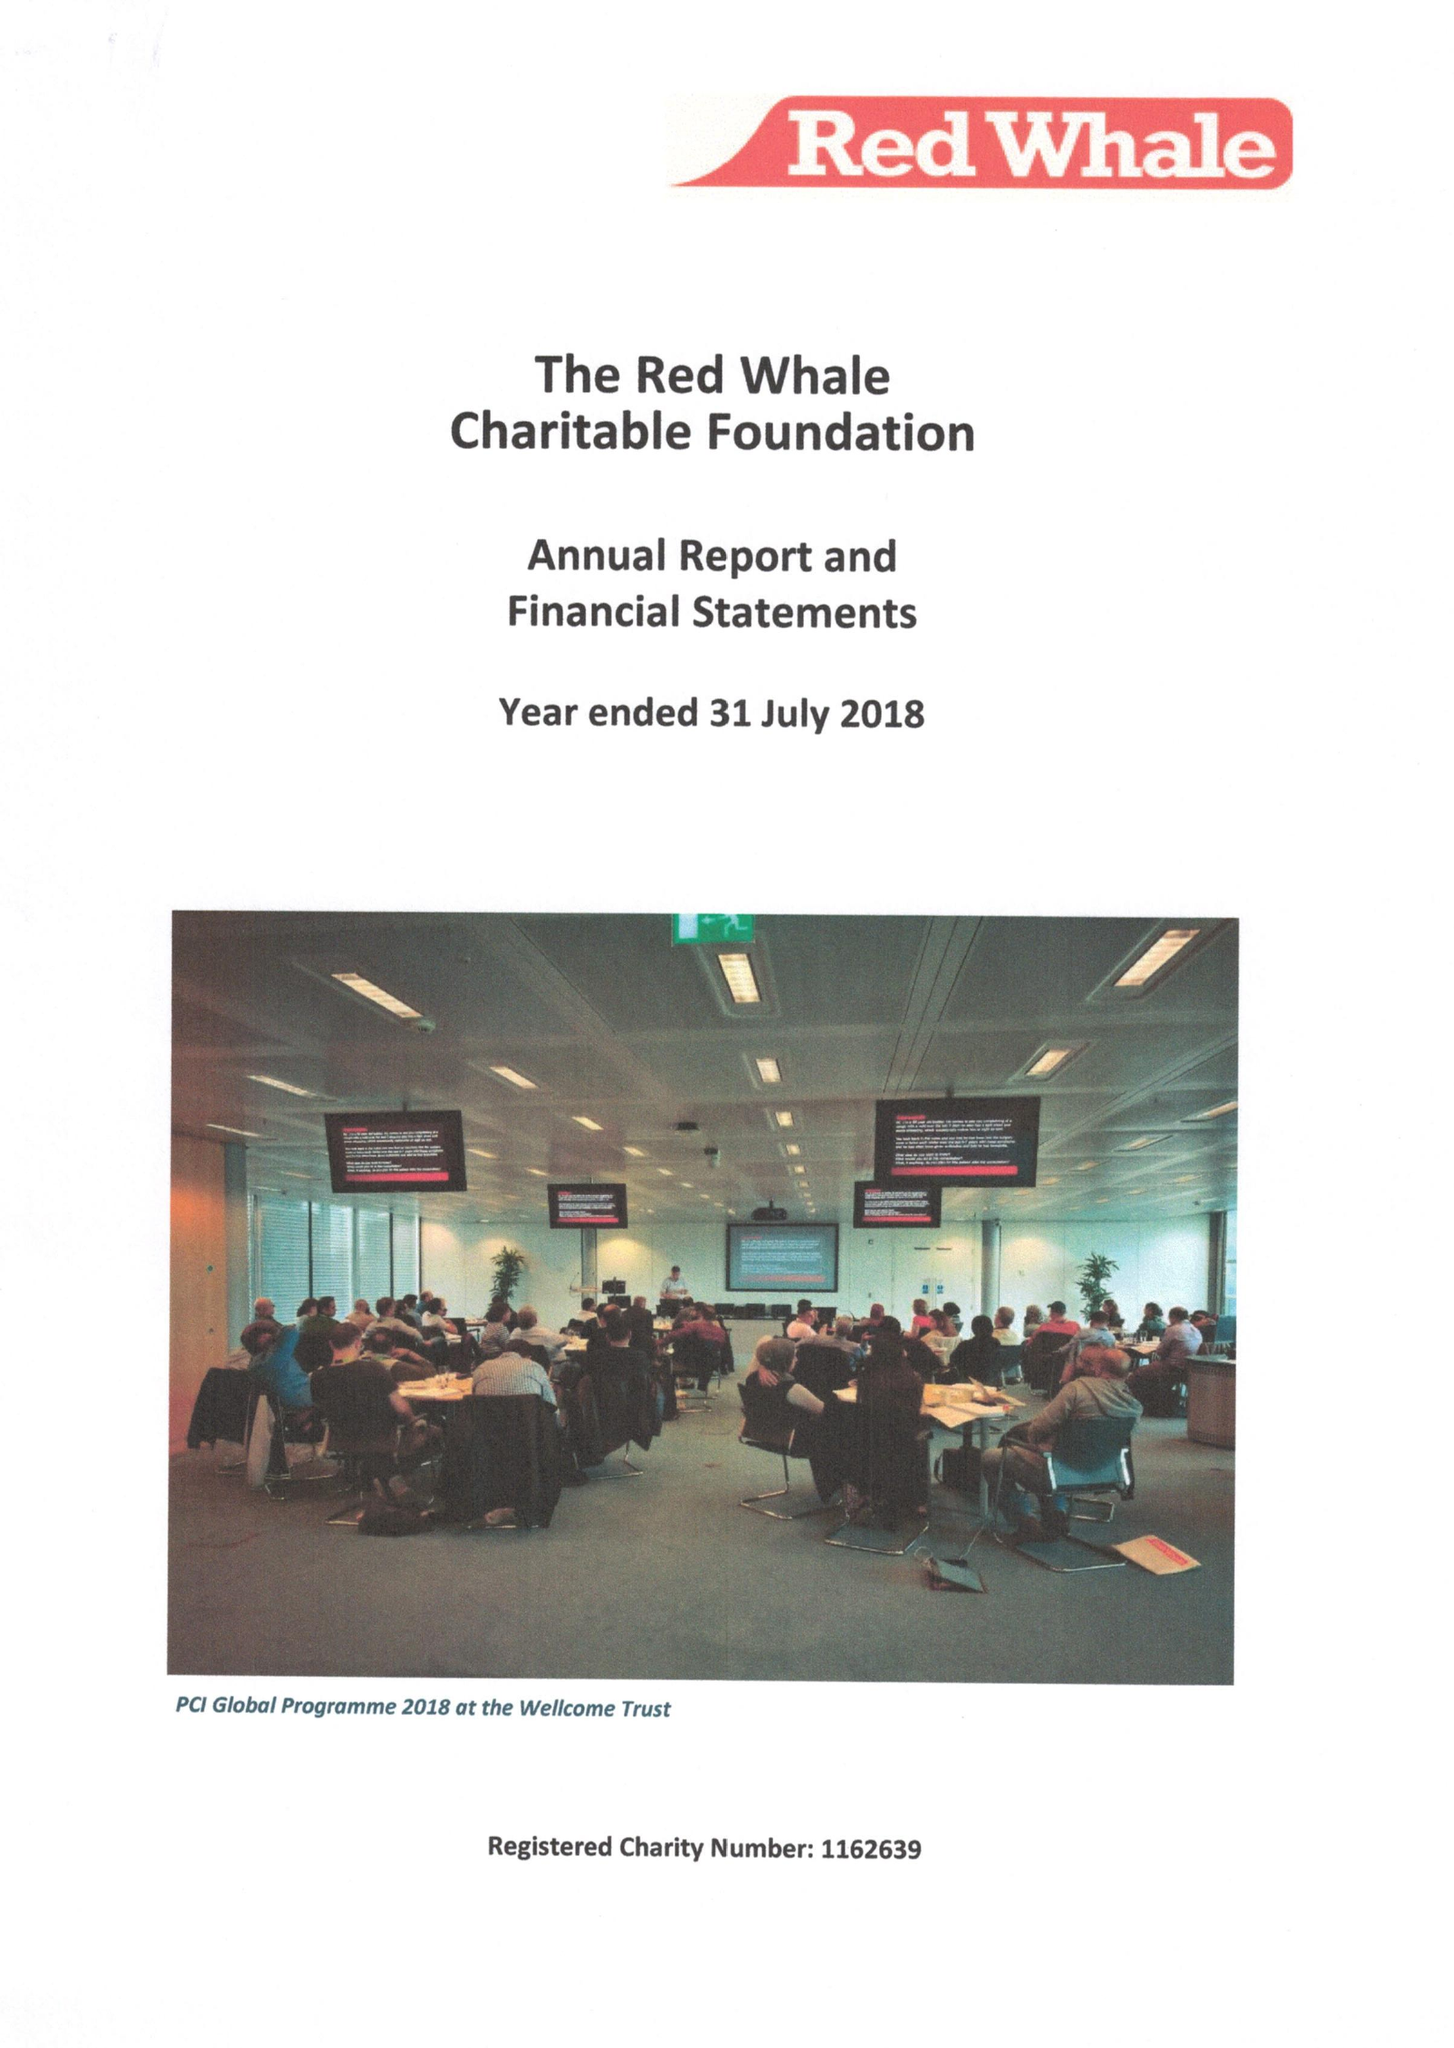What is the value for the spending_annually_in_british_pounds?
Answer the question using a single word or phrase. 91608.00 